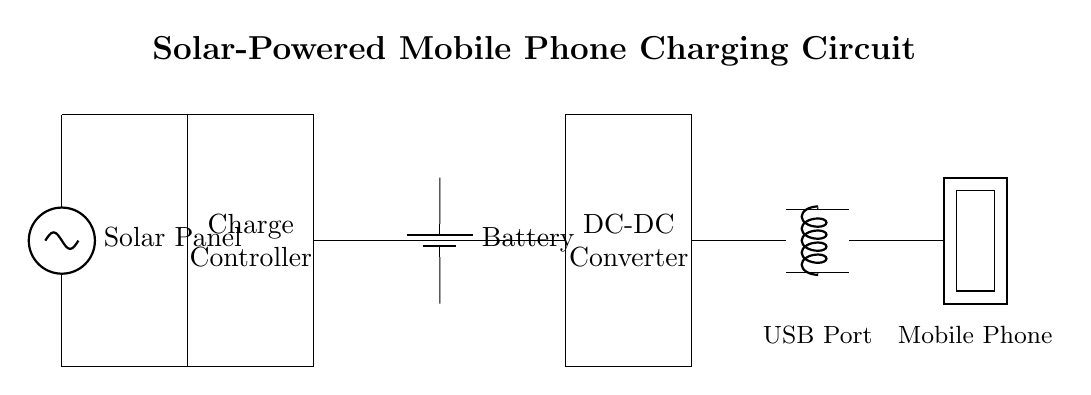What component converts solar energy? The circuit shows a solar panel, which is responsible for converting solar energy into electrical energy.
Answer: Solar panel What type of controller is used in the circuit? The circuit includes a charge controller, which regulates the voltage and current coming from the solar panel to prevent overcharging the battery.
Answer: Charge controller How many main components are in this circuit? The circuit has five main components: a solar panel, charge controller, battery, DC-DC converter, and USB port.
Answer: Five What is the purpose of the USB port? The USB port in the circuit is used for connecting mobile phones or other devices for charging purposes, providing an output voltage suitable for charging.
Answer: Charging What is the role of the DC-DC converter in the circuit? The DC-DC converter adjusts the voltage level to ensure that the device being charged receives the correct voltage, which is necessary for safe and efficient charging.
Answer: Voltage adjustment Which component stores energy in the circuit? The battery is the component in the circuit that stores energy generated from the solar panel for later use, particularly for charging devices when sunlight is not available.
Answer: Battery What is the input source for the charging circuit? The input source for this charging circuit is the solar panel, which provides the initial electrical energy from sunlight to the entire system.
Answer: Solar panel 